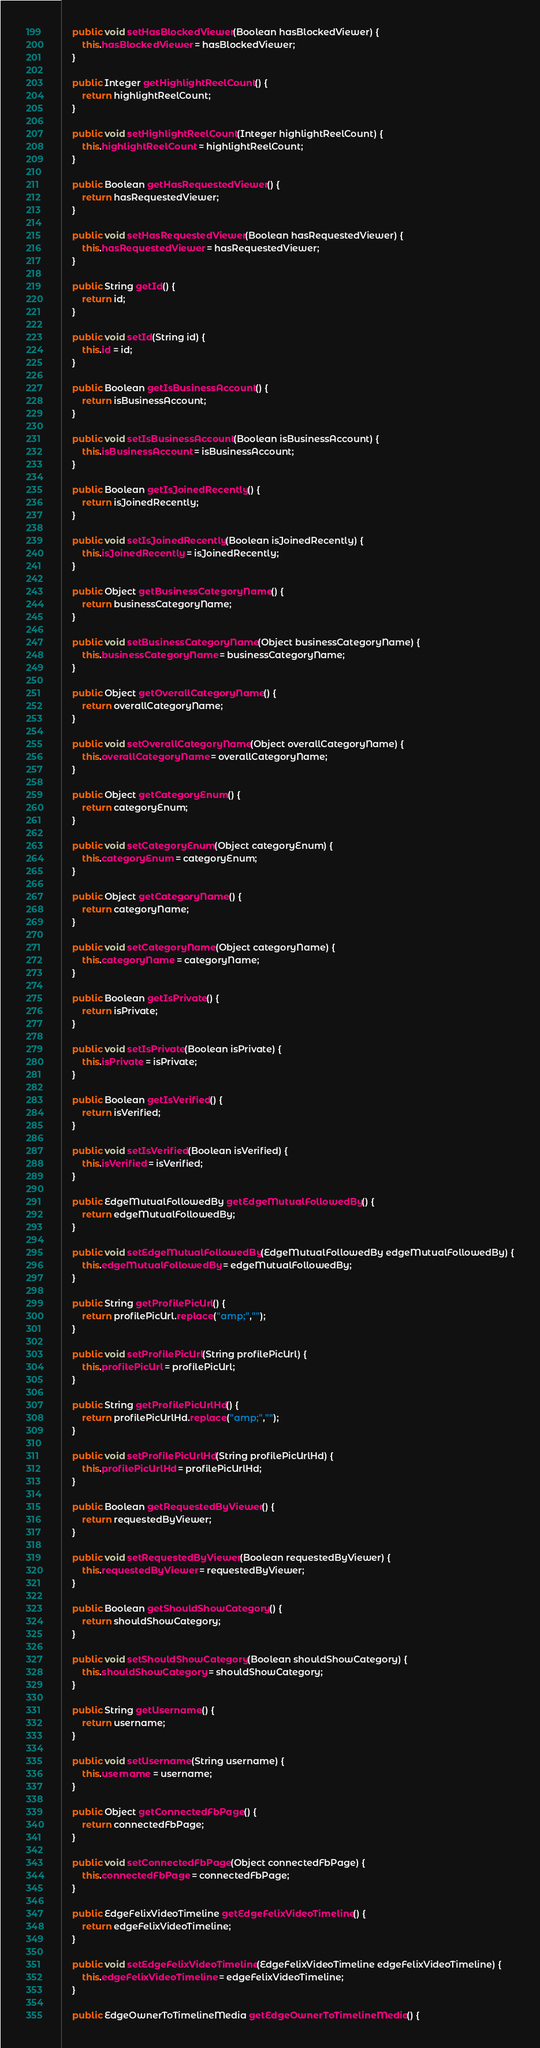Convert code to text. <code><loc_0><loc_0><loc_500><loc_500><_Java_>
    public void setHasBlockedViewer(Boolean hasBlockedViewer) {
        this.hasBlockedViewer = hasBlockedViewer;
    }

    public Integer getHighlightReelCount() {
        return highlightReelCount;
    }

    public void setHighlightReelCount(Integer highlightReelCount) {
        this.highlightReelCount = highlightReelCount;
    }

    public Boolean getHasRequestedViewer() {
        return hasRequestedViewer;
    }

    public void setHasRequestedViewer(Boolean hasRequestedViewer) {
        this.hasRequestedViewer = hasRequestedViewer;
    }

    public String getId() {
        return id;
    }

    public void setId(String id) {
        this.id = id;
    }

    public Boolean getIsBusinessAccount() {
        return isBusinessAccount;
    }

    public void setIsBusinessAccount(Boolean isBusinessAccount) {
        this.isBusinessAccount = isBusinessAccount;
    }

    public Boolean getIsJoinedRecently() {
        return isJoinedRecently;
    }

    public void setIsJoinedRecently(Boolean isJoinedRecently) {
        this.isJoinedRecently = isJoinedRecently;
    }

    public Object getBusinessCategoryName() {
        return businessCategoryName;
    }

    public void setBusinessCategoryName(Object businessCategoryName) {
        this.businessCategoryName = businessCategoryName;
    }

    public Object getOverallCategoryName() {
        return overallCategoryName;
    }

    public void setOverallCategoryName(Object overallCategoryName) {
        this.overallCategoryName = overallCategoryName;
    }

    public Object getCategoryEnum() {
        return categoryEnum;
    }

    public void setCategoryEnum(Object categoryEnum) {
        this.categoryEnum = categoryEnum;
    }

    public Object getCategoryName() {
        return categoryName;
    }

    public void setCategoryName(Object categoryName) {
        this.categoryName = categoryName;
    }

    public Boolean getIsPrivate() {
        return isPrivate;
    }

    public void setIsPrivate(Boolean isPrivate) {
        this.isPrivate = isPrivate;
    }

    public Boolean getIsVerified() {
        return isVerified;
    }

    public void setIsVerified(Boolean isVerified) {
        this.isVerified = isVerified;
    }

    public EdgeMutualFollowedBy getEdgeMutualFollowedBy() {
        return edgeMutualFollowedBy;
    }

    public void setEdgeMutualFollowedBy(EdgeMutualFollowedBy edgeMutualFollowedBy) {
        this.edgeMutualFollowedBy = edgeMutualFollowedBy;
    }

    public String getProfilePicUrl() {
        return profilePicUrl.replace("amp;","");
    }

    public void setProfilePicUrl(String profilePicUrl) {
        this.profilePicUrl = profilePicUrl;
    }

    public String getProfilePicUrlHd() {
        return profilePicUrlHd.replace("amp;","");
    }

    public void setProfilePicUrlHd(String profilePicUrlHd) {
        this.profilePicUrlHd = profilePicUrlHd;
    }

    public Boolean getRequestedByViewer() {
        return requestedByViewer;
    }

    public void setRequestedByViewer(Boolean requestedByViewer) {
        this.requestedByViewer = requestedByViewer;
    }

    public Boolean getShouldShowCategory() {
        return shouldShowCategory;
    }

    public void setShouldShowCategory(Boolean shouldShowCategory) {
        this.shouldShowCategory = shouldShowCategory;
    }

    public String getUsername() {
        return username;
    }

    public void setUsername(String username) {
        this.username = username;
    }

    public Object getConnectedFbPage() {
        return connectedFbPage;
    }

    public void setConnectedFbPage(Object connectedFbPage) {
        this.connectedFbPage = connectedFbPage;
    }

    public EdgeFelixVideoTimeline getEdgeFelixVideoTimeline() {
        return edgeFelixVideoTimeline;
    }

    public void setEdgeFelixVideoTimeline(EdgeFelixVideoTimeline edgeFelixVideoTimeline) {
        this.edgeFelixVideoTimeline = edgeFelixVideoTimeline;
    }

    public EdgeOwnerToTimelineMedia getEdgeOwnerToTimelineMedia() {</code> 